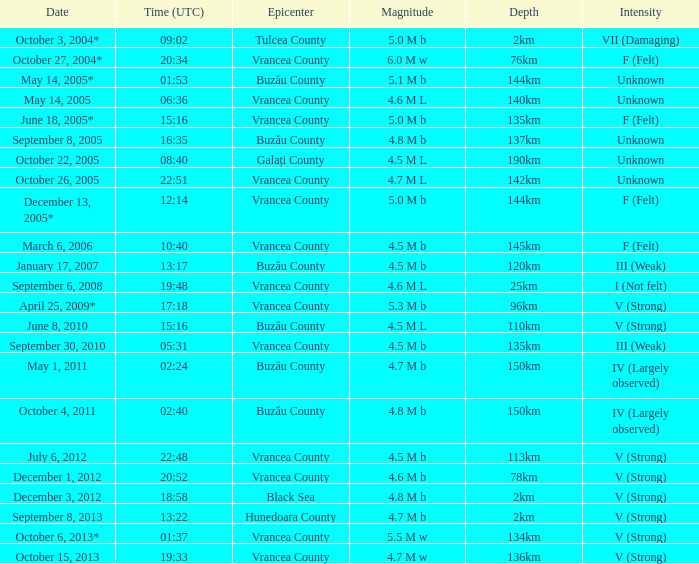With its epicenter in vrancea county and an unknown intensity, what was the magnitude of the earthquake that happened at 06:36? 4.6 M L. 